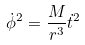<formula> <loc_0><loc_0><loc_500><loc_500>\dot { \phi } ^ { 2 } = \frac { M } { r ^ { 3 } } \dot { t } ^ { 2 }</formula> 